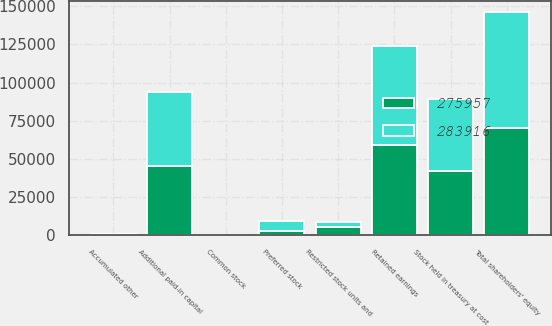<chart> <loc_0><loc_0><loc_500><loc_500><stacked_bar_chart><ecel><fcel>Preferred stock<fcel>Common stock<fcel>Restricted stock units and<fcel>Additional paid-in capital<fcel>Retained earnings<fcel>Accumulated other<fcel>Stock held in treasury at cost<fcel>Total shareholders' equity<nl><fcel>283916<fcel>6200<fcel>8<fcel>3298<fcel>48030<fcel>65223<fcel>193<fcel>46850<fcel>75716<nl><fcel>275957<fcel>3100<fcel>8<fcel>5681<fcel>45553<fcel>58834<fcel>516<fcel>42281<fcel>70379<nl></chart> 